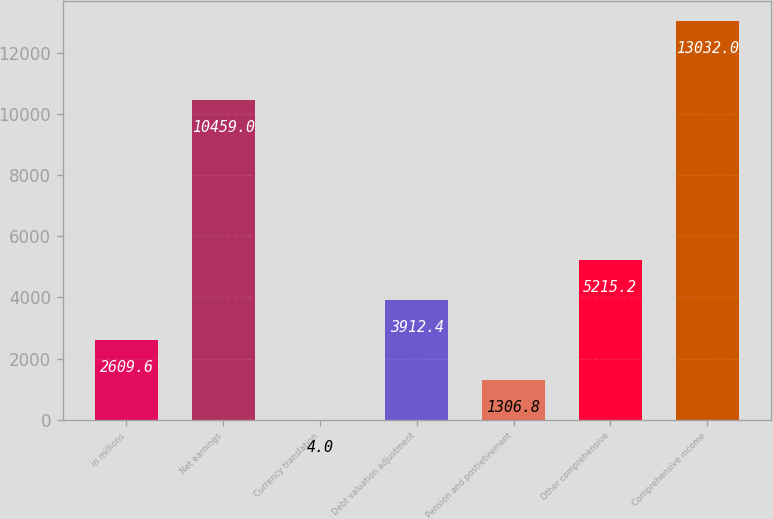Convert chart to OTSL. <chart><loc_0><loc_0><loc_500><loc_500><bar_chart><fcel>in millions<fcel>Net earnings<fcel>Currency translation<fcel>Debt valuation adjustment<fcel>Pension and postretirement<fcel>Other comprehensive<fcel>Comprehensive income<nl><fcel>2609.6<fcel>10459<fcel>4<fcel>3912.4<fcel>1306.8<fcel>5215.2<fcel>13032<nl></chart> 